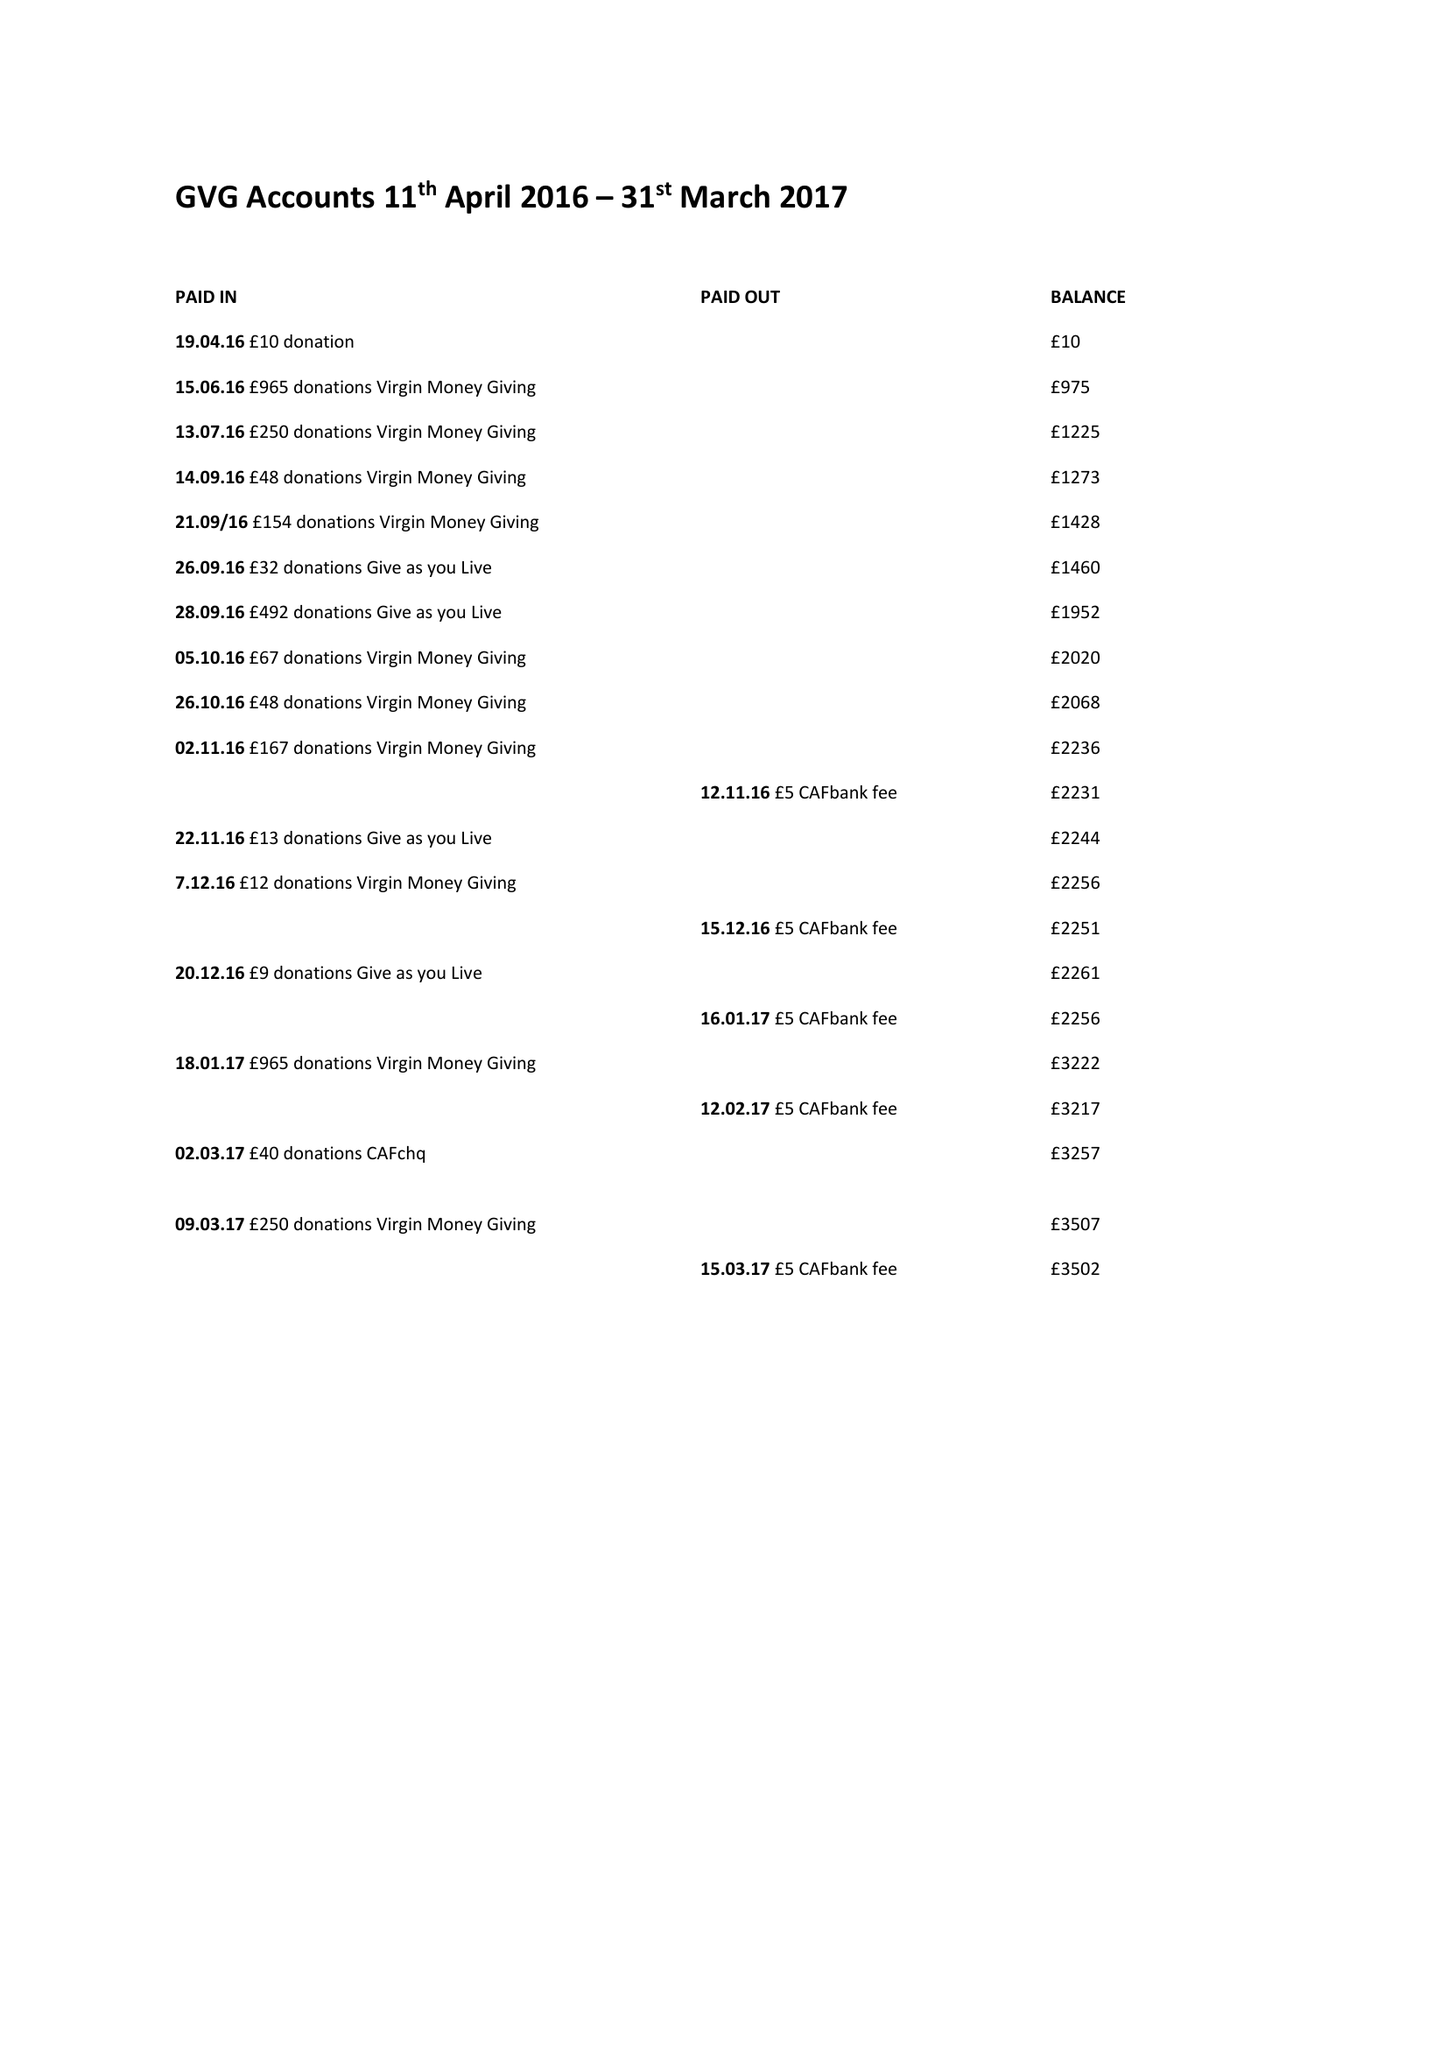What is the value for the spending_annually_in_british_pounds?
Answer the question using a single word or phrase. 25.00 